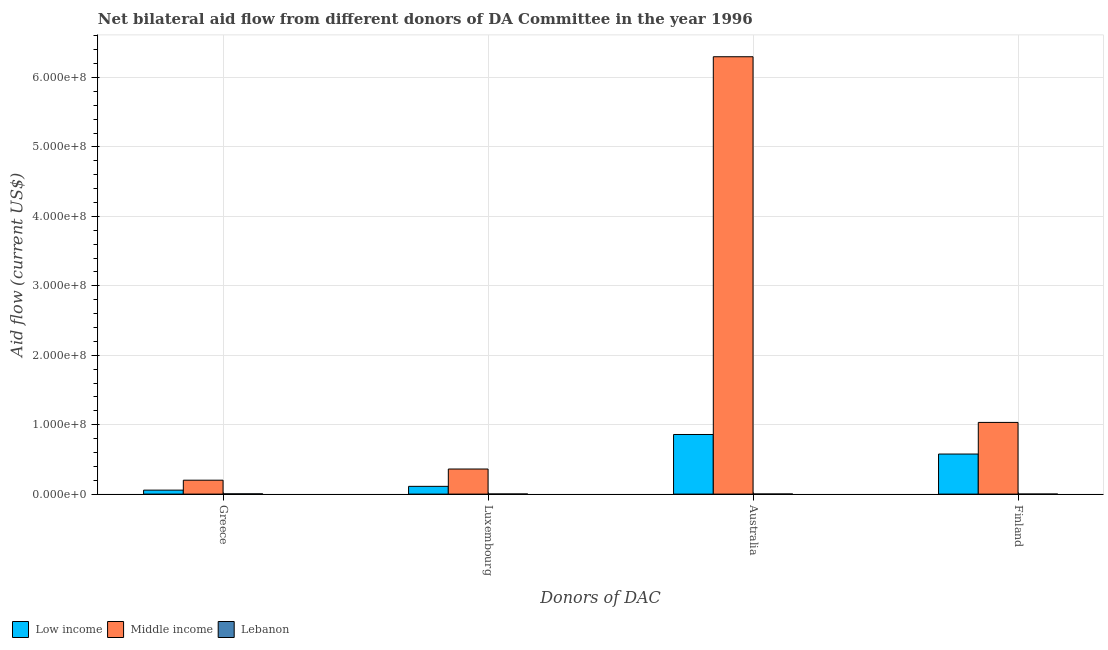How many different coloured bars are there?
Your answer should be compact. 3. How many groups of bars are there?
Provide a short and direct response. 4. Are the number of bars on each tick of the X-axis equal?
Offer a very short reply. Yes. How many bars are there on the 3rd tick from the left?
Make the answer very short. 3. How many bars are there on the 2nd tick from the right?
Ensure brevity in your answer.  3. What is the label of the 4th group of bars from the left?
Offer a very short reply. Finland. What is the amount of aid given by australia in Low income?
Keep it short and to the point. 8.58e+07. Across all countries, what is the maximum amount of aid given by luxembourg?
Your response must be concise. 3.61e+07. Across all countries, what is the minimum amount of aid given by australia?
Offer a terse response. 1.20e+05. In which country was the amount of aid given by greece minimum?
Ensure brevity in your answer.  Lebanon. What is the total amount of aid given by australia in the graph?
Offer a very short reply. 7.16e+08. What is the difference between the amount of aid given by australia in Lebanon and that in Low income?
Your answer should be very brief. -8.57e+07. What is the difference between the amount of aid given by greece in Low income and the amount of aid given by australia in Middle income?
Your response must be concise. -6.24e+08. What is the average amount of aid given by australia per country?
Keep it short and to the point. 2.39e+08. What is the difference between the amount of aid given by finland and amount of aid given by greece in Low income?
Your response must be concise. 5.20e+07. In how many countries, is the amount of aid given by luxembourg greater than 560000000 US$?
Your response must be concise. 0. What is the ratio of the amount of aid given by greece in Middle income to that in Low income?
Give a very brief answer. 3.5. Is the difference between the amount of aid given by luxembourg in Middle income and Low income greater than the difference between the amount of aid given by finland in Middle income and Low income?
Keep it short and to the point. No. What is the difference between the highest and the second highest amount of aid given by luxembourg?
Keep it short and to the point. 2.50e+07. What is the difference between the highest and the lowest amount of aid given by greece?
Ensure brevity in your answer.  1.97e+07. Is the sum of the amount of aid given by luxembourg in Middle income and Lebanon greater than the maximum amount of aid given by finland across all countries?
Provide a succinct answer. No. Is it the case that in every country, the sum of the amount of aid given by australia and amount of aid given by luxembourg is greater than the sum of amount of aid given by greece and amount of aid given by finland?
Keep it short and to the point. No. What does the 1st bar from the right in Finland represents?
Your response must be concise. Lebanon. Is it the case that in every country, the sum of the amount of aid given by greece and amount of aid given by luxembourg is greater than the amount of aid given by australia?
Ensure brevity in your answer.  No. How many bars are there?
Offer a very short reply. 12. Does the graph contain grids?
Provide a succinct answer. Yes. What is the title of the graph?
Ensure brevity in your answer.  Net bilateral aid flow from different donors of DA Committee in the year 1996. Does "Finland" appear as one of the legend labels in the graph?
Provide a short and direct response. No. What is the label or title of the X-axis?
Make the answer very short. Donors of DAC. What is the Aid flow (current US$) in Low income in Greece?
Provide a succinct answer. 5.72e+06. What is the Aid flow (current US$) in Middle income in Greece?
Give a very brief answer. 2.00e+07. What is the Aid flow (current US$) in Low income in Luxembourg?
Your answer should be compact. 1.12e+07. What is the Aid flow (current US$) in Middle income in Luxembourg?
Offer a very short reply. 3.61e+07. What is the Aid flow (current US$) in Low income in Australia?
Offer a very short reply. 8.58e+07. What is the Aid flow (current US$) of Middle income in Australia?
Your answer should be very brief. 6.30e+08. What is the Aid flow (current US$) of Low income in Finland?
Make the answer very short. 5.77e+07. What is the Aid flow (current US$) of Middle income in Finland?
Your response must be concise. 1.03e+08. What is the Aid flow (current US$) of Lebanon in Finland?
Your answer should be compact. 2.00e+04. Across all Donors of DAC, what is the maximum Aid flow (current US$) of Low income?
Your answer should be very brief. 8.58e+07. Across all Donors of DAC, what is the maximum Aid flow (current US$) in Middle income?
Make the answer very short. 6.30e+08. Across all Donors of DAC, what is the minimum Aid flow (current US$) in Low income?
Provide a succinct answer. 5.72e+06. Across all Donors of DAC, what is the minimum Aid flow (current US$) of Middle income?
Give a very brief answer. 2.00e+07. Across all Donors of DAC, what is the minimum Aid flow (current US$) in Lebanon?
Your answer should be compact. 2.00e+04. What is the total Aid flow (current US$) in Low income in the graph?
Make the answer very short. 1.60e+08. What is the total Aid flow (current US$) in Middle income in the graph?
Provide a short and direct response. 7.89e+08. What is the total Aid flow (current US$) in Lebanon in the graph?
Make the answer very short. 6.30e+05. What is the difference between the Aid flow (current US$) in Low income in Greece and that in Luxembourg?
Give a very brief answer. -5.45e+06. What is the difference between the Aid flow (current US$) in Middle income in Greece and that in Luxembourg?
Ensure brevity in your answer.  -1.61e+07. What is the difference between the Aid flow (current US$) in Lebanon in Greece and that in Luxembourg?
Provide a short and direct response. 1.90e+05. What is the difference between the Aid flow (current US$) in Low income in Greece and that in Australia?
Make the answer very short. -8.01e+07. What is the difference between the Aid flow (current US$) of Middle income in Greece and that in Australia?
Your answer should be very brief. -6.10e+08. What is the difference between the Aid flow (current US$) in Lebanon in Greece and that in Australia?
Offer a very short reply. 2.20e+05. What is the difference between the Aid flow (current US$) of Low income in Greece and that in Finland?
Make the answer very short. -5.20e+07. What is the difference between the Aid flow (current US$) in Middle income in Greece and that in Finland?
Provide a succinct answer. -8.32e+07. What is the difference between the Aid flow (current US$) of Low income in Luxembourg and that in Australia?
Offer a very short reply. -7.47e+07. What is the difference between the Aid flow (current US$) in Middle income in Luxembourg and that in Australia?
Offer a very short reply. -5.94e+08. What is the difference between the Aid flow (current US$) of Lebanon in Luxembourg and that in Australia?
Your answer should be compact. 3.00e+04. What is the difference between the Aid flow (current US$) of Low income in Luxembourg and that in Finland?
Offer a terse response. -4.65e+07. What is the difference between the Aid flow (current US$) in Middle income in Luxembourg and that in Finland?
Your response must be concise. -6.71e+07. What is the difference between the Aid flow (current US$) of Lebanon in Luxembourg and that in Finland?
Provide a succinct answer. 1.30e+05. What is the difference between the Aid flow (current US$) in Low income in Australia and that in Finland?
Ensure brevity in your answer.  2.81e+07. What is the difference between the Aid flow (current US$) in Middle income in Australia and that in Finland?
Provide a short and direct response. 5.27e+08. What is the difference between the Aid flow (current US$) of Low income in Greece and the Aid flow (current US$) of Middle income in Luxembourg?
Keep it short and to the point. -3.04e+07. What is the difference between the Aid flow (current US$) in Low income in Greece and the Aid flow (current US$) in Lebanon in Luxembourg?
Provide a short and direct response. 5.57e+06. What is the difference between the Aid flow (current US$) in Middle income in Greece and the Aid flow (current US$) in Lebanon in Luxembourg?
Your answer should be very brief. 1.99e+07. What is the difference between the Aid flow (current US$) in Low income in Greece and the Aid flow (current US$) in Middle income in Australia?
Offer a very short reply. -6.24e+08. What is the difference between the Aid flow (current US$) in Low income in Greece and the Aid flow (current US$) in Lebanon in Australia?
Make the answer very short. 5.60e+06. What is the difference between the Aid flow (current US$) in Middle income in Greece and the Aid flow (current US$) in Lebanon in Australia?
Make the answer very short. 1.99e+07. What is the difference between the Aid flow (current US$) of Low income in Greece and the Aid flow (current US$) of Middle income in Finland?
Your answer should be very brief. -9.75e+07. What is the difference between the Aid flow (current US$) of Low income in Greece and the Aid flow (current US$) of Lebanon in Finland?
Provide a short and direct response. 5.70e+06. What is the difference between the Aid flow (current US$) in Middle income in Greece and the Aid flow (current US$) in Lebanon in Finland?
Provide a short and direct response. 2.00e+07. What is the difference between the Aid flow (current US$) in Low income in Luxembourg and the Aid flow (current US$) in Middle income in Australia?
Keep it short and to the point. -6.19e+08. What is the difference between the Aid flow (current US$) of Low income in Luxembourg and the Aid flow (current US$) of Lebanon in Australia?
Your answer should be very brief. 1.10e+07. What is the difference between the Aid flow (current US$) in Middle income in Luxembourg and the Aid flow (current US$) in Lebanon in Australia?
Give a very brief answer. 3.60e+07. What is the difference between the Aid flow (current US$) in Low income in Luxembourg and the Aid flow (current US$) in Middle income in Finland?
Give a very brief answer. -9.21e+07. What is the difference between the Aid flow (current US$) in Low income in Luxembourg and the Aid flow (current US$) in Lebanon in Finland?
Your answer should be very brief. 1.12e+07. What is the difference between the Aid flow (current US$) in Middle income in Luxembourg and the Aid flow (current US$) in Lebanon in Finland?
Ensure brevity in your answer.  3.61e+07. What is the difference between the Aid flow (current US$) in Low income in Australia and the Aid flow (current US$) in Middle income in Finland?
Offer a terse response. -1.74e+07. What is the difference between the Aid flow (current US$) of Low income in Australia and the Aid flow (current US$) of Lebanon in Finland?
Your response must be concise. 8.58e+07. What is the difference between the Aid flow (current US$) of Middle income in Australia and the Aid flow (current US$) of Lebanon in Finland?
Your response must be concise. 6.30e+08. What is the average Aid flow (current US$) in Low income per Donors of DAC?
Provide a short and direct response. 4.01e+07. What is the average Aid flow (current US$) in Middle income per Donors of DAC?
Provide a short and direct response. 1.97e+08. What is the average Aid flow (current US$) in Lebanon per Donors of DAC?
Provide a succinct answer. 1.58e+05. What is the difference between the Aid flow (current US$) in Low income and Aid flow (current US$) in Middle income in Greece?
Provide a succinct answer. -1.43e+07. What is the difference between the Aid flow (current US$) of Low income and Aid flow (current US$) of Lebanon in Greece?
Make the answer very short. 5.38e+06. What is the difference between the Aid flow (current US$) in Middle income and Aid flow (current US$) in Lebanon in Greece?
Ensure brevity in your answer.  1.97e+07. What is the difference between the Aid flow (current US$) of Low income and Aid flow (current US$) of Middle income in Luxembourg?
Make the answer very short. -2.50e+07. What is the difference between the Aid flow (current US$) in Low income and Aid flow (current US$) in Lebanon in Luxembourg?
Offer a terse response. 1.10e+07. What is the difference between the Aid flow (current US$) in Middle income and Aid flow (current US$) in Lebanon in Luxembourg?
Your response must be concise. 3.60e+07. What is the difference between the Aid flow (current US$) of Low income and Aid flow (current US$) of Middle income in Australia?
Your response must be concise. -5.44e+08. What is the difference between the Aid flow (current US$) in Low income and Aid flow (current US$) in Lebanon in Australia?
Provide a short and direct response. 8.57e+07. What is the difference between the Aid flow (current US$) of Middle income and Aid flow (current US$) of Lebanon in Australia?
Your response must be concise. 6.30e+08. What is the difference between the Aid flow (current US$) of Low income and Aid flow (current US$) of Middle income in Finland?
Offer a very short reply. -4.55e+07. What is the difference between the Aid flow (current US$) of Low income and Aid flow (current US$) of Lebanon in Finland?
Provide a short and direct response. 5.77e+07. What is the difference between the Aid flow (current US$) in Middle income and Aid flow (current US$) in Lebanon in Finland?
Your answer should be compact. 1.03e+08. What is the ratio of the Aid flow (current US$) in Low income in Greece to that in Luxembourg?
Your response must be concise. 0.51. What is the ratio of the Aid flow (current US$) of Middle income in Greece to that in Luxembourg?
Your answer should be compact. 0.55. What is the ratio of the Aid flow (current US$) of Lebanon in Greece to that in Luxembourg?
Ensure brevity in your answer.  2.27. What is the ratio of the Aid flow (current US$) of Low income in Greece to that in Australia?
Offer a terse response. 0.07. What is the ratio of the Aid flow (current US$) of Middle income in Greece to that in Australia?
Your response must be concise. 0.03. What is the ratio of the Aid flow (current US$) of Lebanon in Greece to that in Australia?
Provide a short and direct response. 2.83. What is the ratio of the Aid flow (current US$) in Low income in Greece to that in Finland?
Your answer should be compact. 0.1. What is the ratio of the Aid flow (current US$) of Middle income in Greece to that in Finland?
Ensure brevity in your answer.  0.19. What is the ratio of the Aid flow (current US$) of Lebanon in Greece to that in Finland?
Provide a succinct answer. 17. What is the ratio of the Aid flow (current US$) in Low income in Luxembourg to that in Australia?
Your answer should be compact. 0.13. What is the ratio of the Aid flow (current US$) in Middle income in Luxembourg to that in Australia?
Make the answer very short. 0.06. What is the ratio of the Aid flow (current US$) in Lebanon in Luxembourg to that in Australia?
Your answer should be compact. 1.25. What is the ratio of the Aid flow (current US$) of Low income in Luxembourg to that in Finland?
Make the answer very short. 0.19. What is the ratio of the Aid flow (current US$) of Middle income in Luxembourg to that in Finland?
Your answer should be very brief. 0.35. What is the ratio of the Aid flow (current US$) of Low income in Australia to that in Finland?
Give a very brief answer. 1.49. What is the ratio of the Aid flow (current US$) in Middle income in Australia to that in Finland?
Offer a terse response. 6.1. What is the difference between the highest and the second highest Aid flow (current US$) in Low income?
Offer a very short reply. 2.81e+07. What is the difference between the highest and the second highest Aid flow (current US$) of Middle income?
Ensure brevity in your answer.  5.27e+08. What is the difference between the highest and the second highest Aid flow (current US$) of Lebanon?
Your answer should be compact. 1.90e+05. What is the difference between the highest and the lowest Aid flow (current US$) in Low income?
Make the answer very short. 8.01e+07. What is the difference between the highest and the lowest Aid flow (current US$) of Middle income?
Keep it short and to the point. 6.10e+08. What is the difference between the highest and the lowest Aid flow (current US$) in Lebanon?
Offer a terse response. 3.20e+05. 